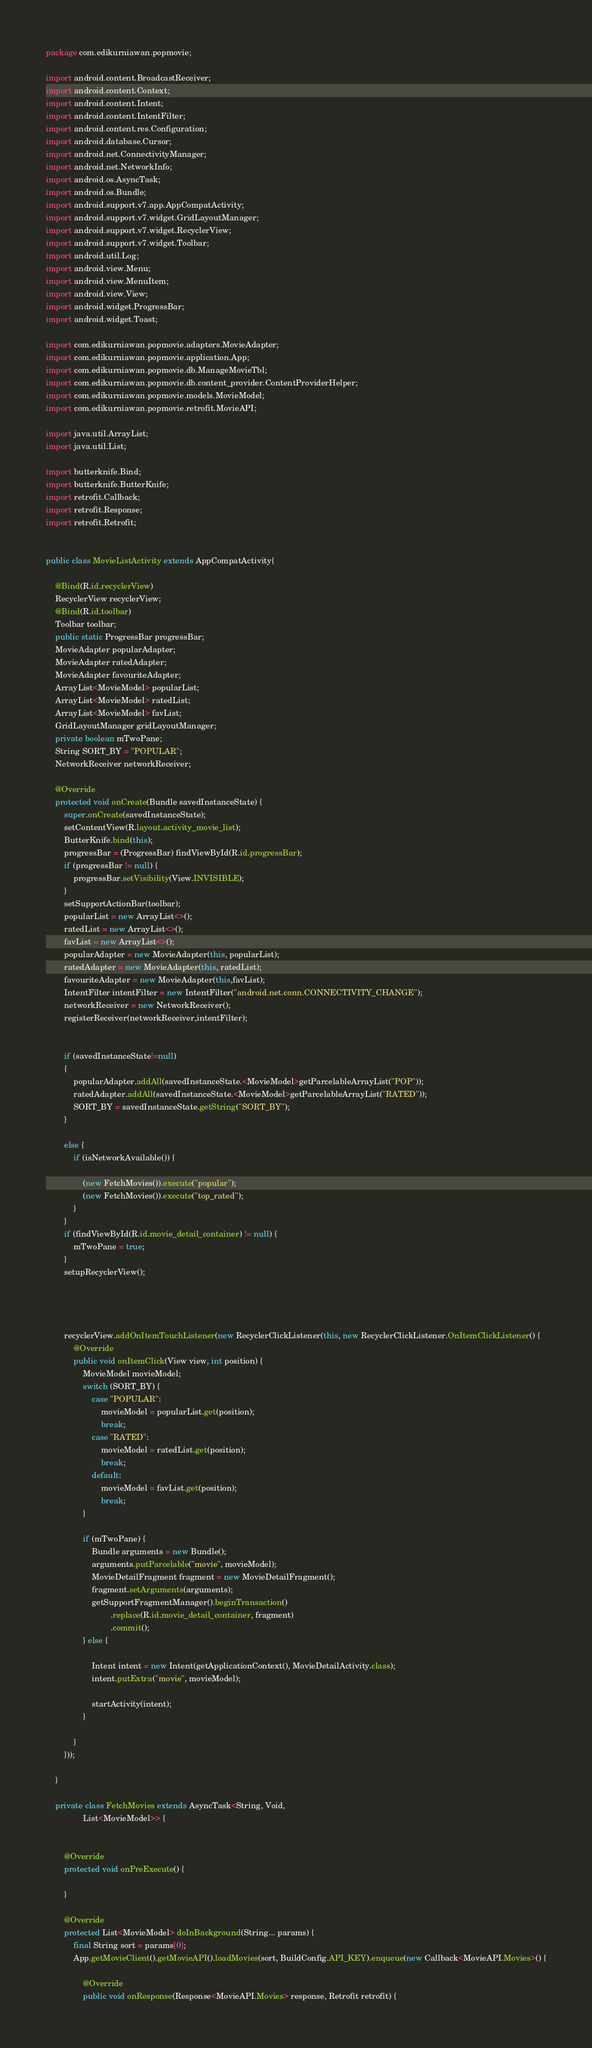Convert code to text. <code><loc_0><loc_0><loc_500><loc_500><_Java_>package com.edikurniawan.popmovie;

import android.content.BroadcastReceiver;
import android.content.Context;
import android.content.Intent;
import android.content.IntentFilter;
import android.content.res.Configuration;
import android.database.Cursor;
import android.net.ConnectivityManager;
import android.net.NetworkInfo;
import android.os.AsyncTask;
import android.os.Bundle;
import android.support.v7.app.AppCompatActivity;
import android.support.v7.widget.GridLayoutManager;
import android.support.v7.widget.RecyclerView;
import android.support.v7.widget.Toolbar;
import android.util.Log;
import android.view.Menu;
import android.view.MenuItem;
import android.view.View;
import android.widget.ProgressBar;
import android.widget.Toast;

import com.edikurniawan.popmovie.adapters.MovieAdapter;
import com.edikurniawan.popmovie.application.App;
import com.edikurniawan.popmovie.db.ManageMovieTbl;
import com.edikurniawan.popmovie.db.content_provider.ContentProviderHelper;
import com.edikurniawan.popmovie.models.MovieModel;
import com.edikurniawan.popmovie.retrofit.MovieAPI;

import java.util.ArrayList;
import java.util.List;

import butterknife.Bind;
import butterknife.ButterKnife;
import retrofit.Callback;
import retrofit.Response;
import retrofit.Retrofit;


public class MovieListActivity extends AppCompatActivity{

    @Bind(R.id.recyclerView)
    RecyclerView recyclerView;
    @Bind(R.id.toolbar)
    Toolbar toolbar;
    public static ProgressBar progressBar;
    MovieAdapter popularAdapter;
    MovieAdapter ratedAdapter;
    MovieAdapter favouriteAdapter;
    ArrayList<MovieModel> popularList;
    ArrayList<MovieModel> ratedList;
    ArrayList<MovieModel> favList;
    GridLayoutManager gridLayoutManager;
    private boolean mTwoPane;
    String SORT_BY = "POPULAR";
    NetworkReceiver networkReceiver;

    @Override
    protected void onCreate(Bundle savedInstanceState) {
        super.onCreate(savedInstanceState);
        setContentView(R.layout.activity_movie_list);
        ButterKnife.bind(this);
        progressBar = (ProgressBar) findViewById(R.id.progressBar);
        if (progressBar != null) {
            progressBar.setVisibility(View.INVISIBLE);
        }
        setSupportActionBar(toolbar);
        popularList = new ArrayList<>();
        ratedList = new ArrayList<>();
        favList = new ArrayList<>();
        popularAdapter = new MovieAdapter(this, popularList);
        ratedAdapter = new MovieAdapter(this, ratedList);
        favouriteAdapter = new MovieAdapter(this,favList);
        IntentFilter intentFilter = new IntentFilter("android.net.conn.CONNECTIVITY_CHANGE");
        networkReceiver = new NetworkReceiver();
        registerReceiver(networkReceiver,intentFilter);


        if (savedInstanceState!=null)
        {
            popularAdapter.addAll(savedInstanceState.<MovieModel>getParcelableArrayList("POP"));
            ratedAdapter.addAll(savedInstanceState.<MovieModel>getParcelableArrayList("RATED"));
            SORT_BY = savedInstanceState.getString("SORT_BY");
        }

        else {
            if (isNetworkAvailable()) {

                (new FetchMovies()).execute("popular");
                (new FetchMovies()).execute("top_rated");
            }
        }
        if (findViewById(R.id.movie_detail_container) != null) {
            mTwoPane = true;
        }
        setupRecyclerView();




        recyclerView.addOnItemTouchListener(new RecyclerClickListener(this, new RecyclerClickListener.OnItemClickListener() {
            @Override
            public void onItemClick(View view, int position) {
                MovieModel movieModel;
                switch (SORT_BY) {
                    case "POPULAR":
                        movieModel = popularList.get(position);
                        break;
                    case "RATED":
                        movieModel = ratedList.get(position);
                        break;
                    default:
                        movieModel = favList.get(position);
                        break;
                }

                if (mTwoPane) {
                    Bundle arguments = new Bundle();
                    arguments.putParcelable("movie", movieModel);
                    MovieDetailFragment fragment = new MovieDetailFragment();
                    fragment.setArguments(arguments);
                    getSupportFragmentManager().beginTransaction()
                            .replace(R.id.movie_detail_container, fragment)
                            .commit();
                } else {

                    Intent intent = new Intent(getApplicationContext(), MovieDetailActivity.class);
                    intent.putExtra("movie", movieModel);

                    startActivity(intent);
                }

            }
        }));

    }

    private class FetchMovies extends AsyncTask<String, Void,
                List<MovieModel>> {


        @Override
        protected void onPreExecute() {

        }

        @Override
        protected List<MovieModel> doInBackground(String... params) {
            final String sort = params[0];
            App.getMovieClient().getMovieAPI().loadMovies(sort, BuildConfig.API_KEY).enqueue(new Callback<MovieAPI.Movies>() {

                @Override
                public void onResponse(Response<MovieAPI.Movies> response, Retrofit retrofit) {
</code> 